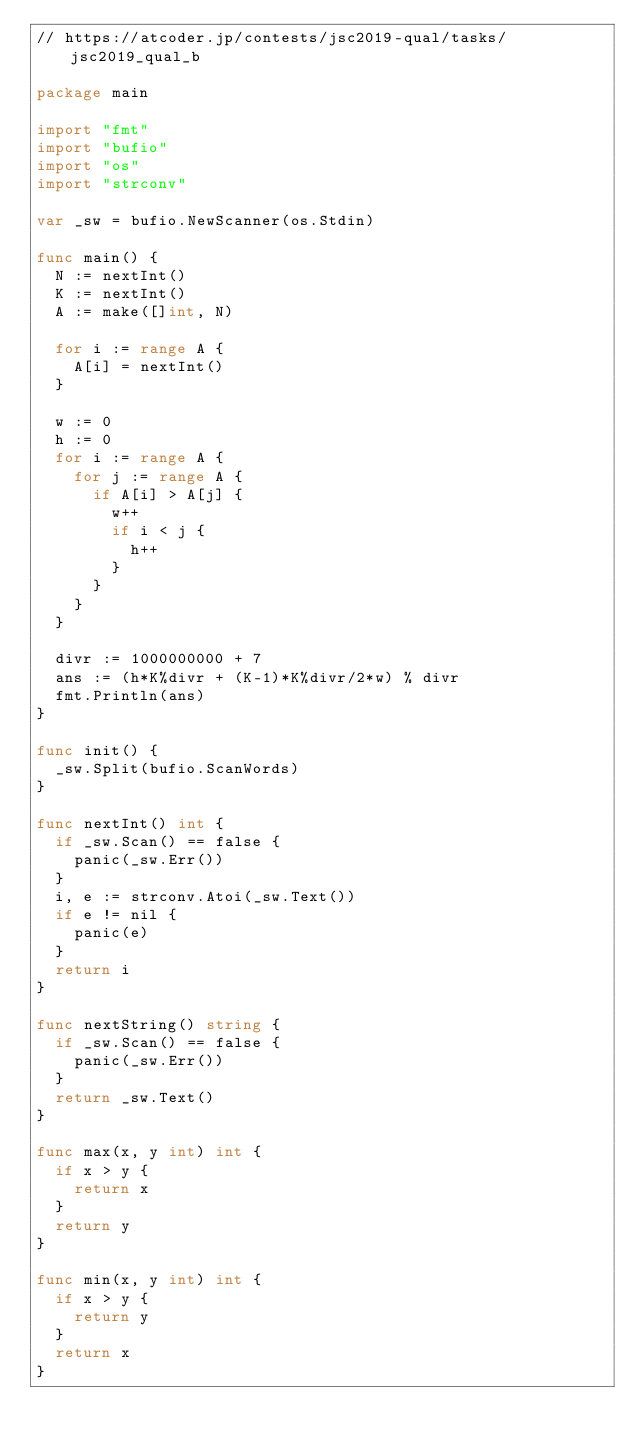<code> <loc_0><loc_0><loc_500><loc_500><_Go_>// https://atcoder.jp/contests/jsc2019-qual/tasks/jsc2019_qual_b

package main

import "fmt"
import "bufio"
import "os"
import "strconv"

var _sw = bufio.NewScanner(os.Stdin)

func main() {
	N := nextInt()
	K := nextInt()
	A := make([]int, N)

	for i := range A {
		A[i] = nextInt()
	}

	w := 0
	h := 0
	for i := range A {
		for j := range A {
			if A[i] > A[j] {
				w++
				if i < j {
					h++
				}
			}
		}
	}

	divr := 1000000000 + 7
	ans := (h*K%divr + (K-1)*K%divr/2*w) % divr
	fmt.Println(ans)
}

func init() {
	_sw.Split(bufio.ScanWords)
}

func nextInt() int {
	if _sw.Scan() == false {
		panic(_sw.Err())
	}
	i, e := strconv.Atoi(_sw.Text())
	if e != nil {
		panic(e)
	}
	return i
}

func nextString() string {
	if _sw.Scan() == false {
		panic(_sw.Err())
	}
	return _sw.Text()
}

func max(x, y int) int {
	if x > y {
		return x
	}
	return y
}

func min(x, y int) int {
	if x > y {
		return y
	}
	return x
}
</code> 